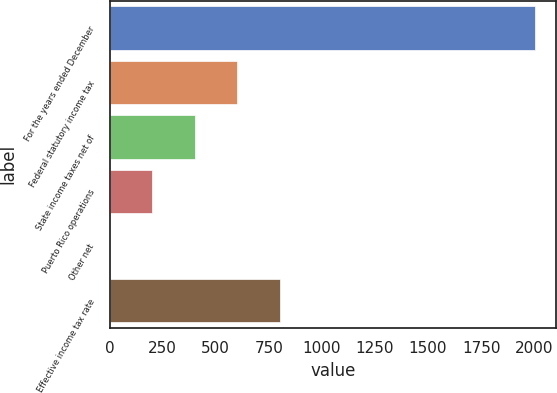<chart> <loc_0><loc_0><loc_500><loc_500><bar_chart><fcel>For the years ended December<fcel>Federal statutory income tax<fcel>State income taxes net of<fcel>Puerto Rico operations<fcel>Other net<fcel>Effective income tax rate<nl><fcel>2002<fcel>600.67<fcel>400.48<fcel>200.29<fcel>0.1<fcel>800.86<nl></chart> 